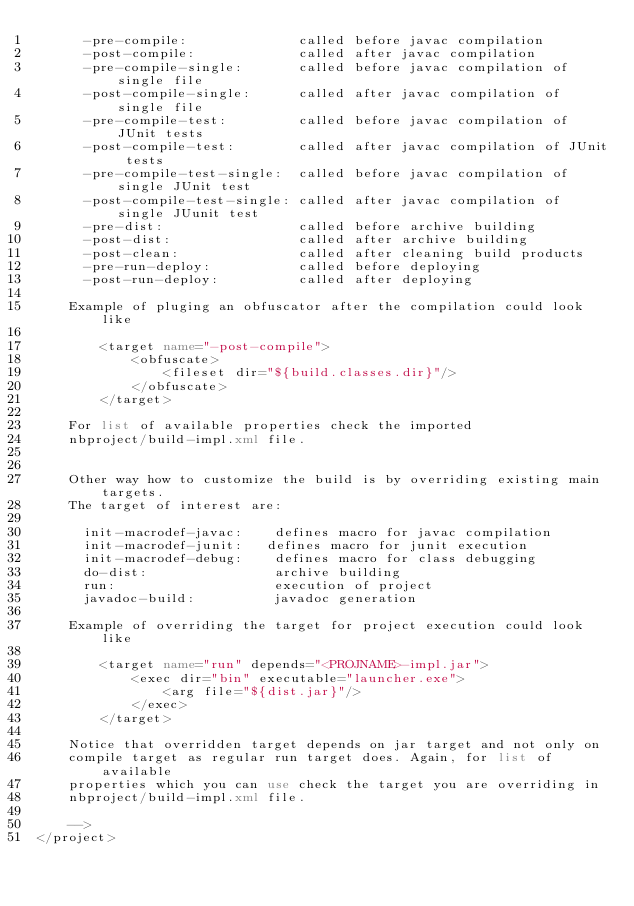<code> <loc_0><loc_0><loc_500><loc_500><_XML_>      -pre-compile:              called before javac compilation 
      -post-compile:             called after javac compilation 
      -pre-compile-single:       called before javac compilation of single file
      -post-compile-single:      called after javac compilation of single file
      -pre-compile-test:         called before javac compilation of JUnit tests
      -post-compile-test:        called after javac compilation of JUnit tests
      -pre-compile-test-single:  called before javac compilation of single JUnit test
      -post-compile-test-single: called after javac compilation of single JUunit test
      -pre-dist:                 called before archive building 
      -post-dist:                called after archive building 
      -post-clean:               called after cleaning build products 
      -pre-run-deploy:           called before deploying
      -post-run-deploy:          called after deploying

    Example of pluging an obfuscator after the compilation could look like 

        <target name="-post-compile">
            <obfuscate>
                <fileset dir="${build.classes.dir}"/>
            </obfuscate>
        </target>

    For list of available properties check the imported 
    nbproject/build-impl.xml file. 


    Other way how to customize the build is by overriding existing main targets.
    The target of interest are: 

      init-macrodef-javac:    defines macro for javac compilation
      init-macrodef-junit:   defines macro for junit execution
      init-macrodef-debug:    defines macro for class debugging
      do-dist:                archive building
      run:                    execution of project 
      javadoc-build:          javadoc generation 

    Example of overriding the target for project execution could look like 

        <target name="run" depends="<PROJNAME>-impl.jar">
            <exec dir="bin" executable="launcher.exe">
                <arg file="${dist.jar}"/>
            </exec>
        </target>

    Notice that overridden target depends on jar target and not only on 
    compile target as regular run target does. Again, for list of available 
    properties which you can use check the target you are overriding in 
    nbproject/build-impl.xml file. 

    -->
</project>
</code> 